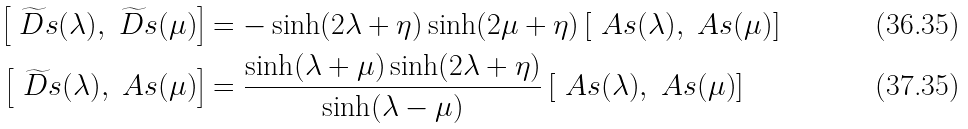Convert formula to latex. <formula><loc_0><loc_0><loc_500><loc_500>\left [ \widetilde { \ D s } ( \lambda ) , \widetilde { \ D s } ( \mu ) \right ] & = - \sinh ( 2 \lambda + \eta ) \sinh ( 2 \mu + \eta ) \left [ \ A s ( \lambda ) , \ A s ( \mu ) \right ] \\ \left [ \widetilde { \ D s } ( \lambda ) , \ A s ( \mu ) \right ] & = \frac { \sinh ( \lambda + \mu ) \sinh ( 2 \lambda + \eta ) } { \sinh ( \lambda - \mu ) } \left [ \ A s ( \lambda ) , \ A s ( \mu ) \right ]</formula> 